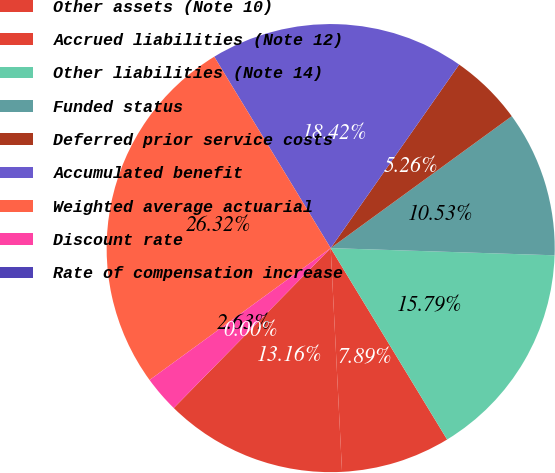Convert chart. <chart><loc_0><loc_0><loc_500><loc_500><pie_chart><fcel>Other assets (Note 10)<fcel>Accrued liabilities (Note 12)<fcel>Other liabilities (Note 14)<fcel>Funded status<fcel>Deferred prior service costs<fcel>Accumulated benefit<fcel>Weighted average actuarial<fcel>Discount rate<fcel>Rate of compensation increase<nl><fcel>13.16%<fcel>7.89%<fcel>15.79%<fcel>10.53%<fcel>5.26%<fcel>18.42%<fcel>26.32%<fcel>2.63%<fcel>0.0%<nl></chart> 